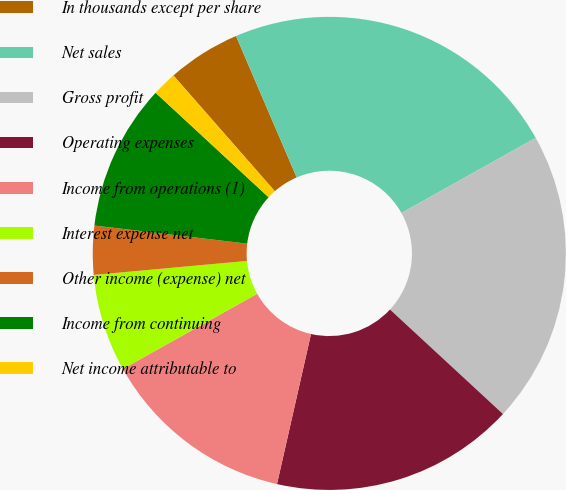<chart> <loc_0><loc_0><loc_500><loc_500><pie_chart><fcel>In thousands except per share<fcel>Net sales<fcel>Gross profit<fcel>Operating expenses<fcel>Income from operations (1)<fcel>Interest expense net<fcel>Other income (expense) net<fcel>Income from continuing<fcel>Net income attributable to<nl><fcel>5.0%<fcel>23.33%<fcel>20.0%<fcel>16.67%<fcel>13.33%<fcel>6.67%<fcel>3.33%<fcel>10.0%<fcel>1.67%<nl></chart> 